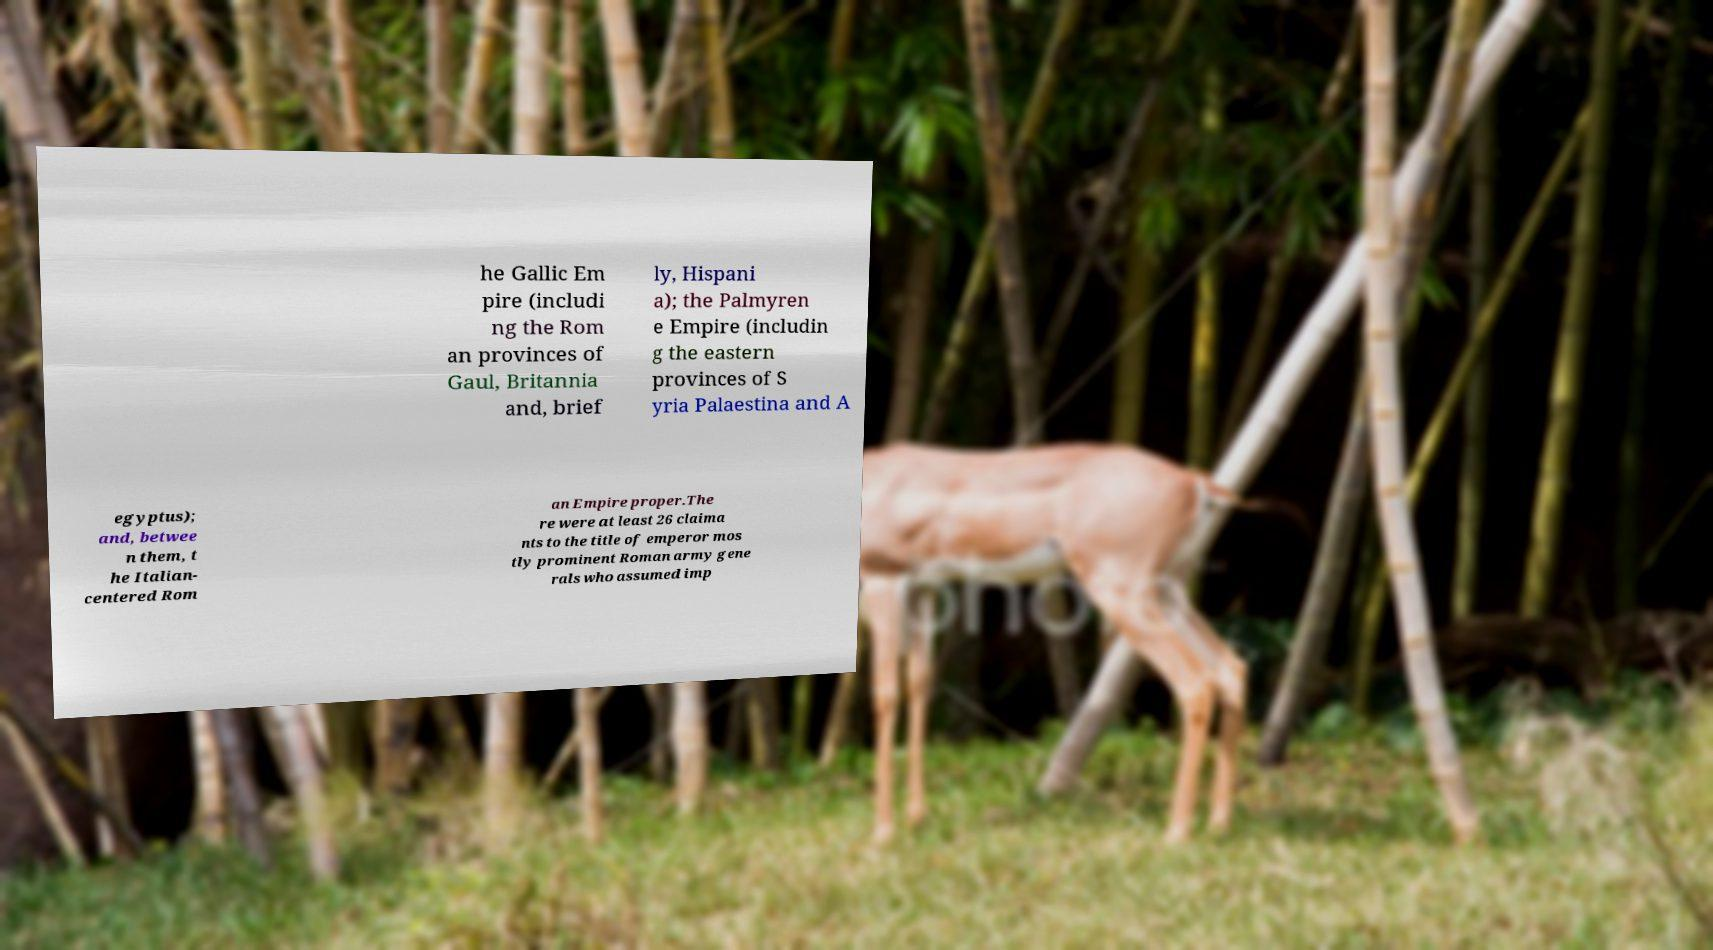Please read and relay the text visible in this image. What does it say? he Gallic Em pire (includi ng the Rom an provinces of Gaul, Britannia and, brief ly, Hispani a); the Palmyren e Empire (includin g the eastern provinces of S yria Palaestina and A egyptus); and, betwee n them, t he Italian- centered Rom an Empire proper.The re were at least 26 claima nts to the title of emperor mos tly prominent Roman army gene rals who assumed imp 